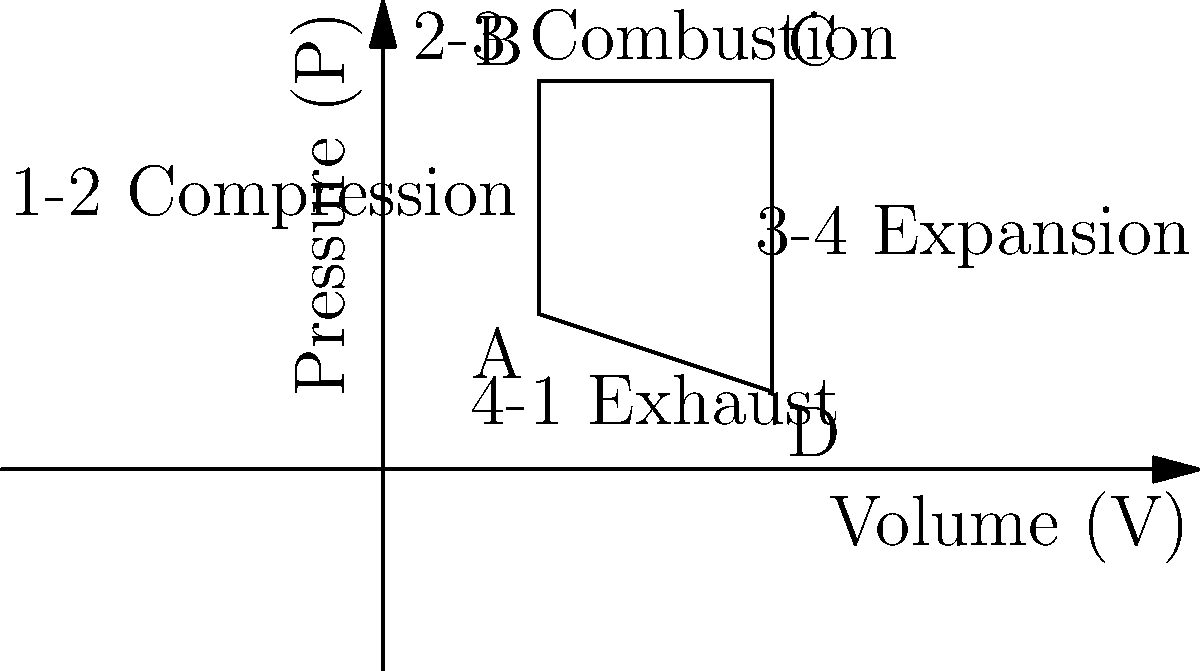As a TV producer who discovered their talents at a coffee shop meetup, you're working on a documentary about engine technology. In the pressure-volume diagram of a four-stroke engine cycle shown above, which process represents the power stroke where the most useful work is produced? To answer this question, let's break down the four-stroke engine cycle and its representation in the pressure-volume (P-V) diagram:

1. The four strokes of the engine cycle are:
   a) Intake
   b) Compression
   c) Power (or Expansion)
   d) Exhaust

2. In the P-V diagram, these strokes are represented by the following processes:
   a) 4-1: Intake (not explicitly shown in this diagram)
   b) 1-2: Compression
   c) 2-3: Combustion (instantaneous process)
   d) 3-4: Expansion (Power stroke)
   e) 4-1: Exhaust

3. The power stroke is where the most useful work is produced. This occurs when the high-pressure gases from combustion expand, pushing the piston down.

4. In the P-V diagram, the power stroke is represented by the expansion process from point 3 to point 4.

5. This process (3-4) shows a decrease in pressure and an increase in volume, which is characteristic of the power stroke.

6. The area under this curve represents the work done by the gas on the piston, which is the useful work output of the engine.

Therefore, the process that represents the power stroke where the most useful work is produced is the expansion process from point 3 to point 4.
Answer: 3-4 Expansion 